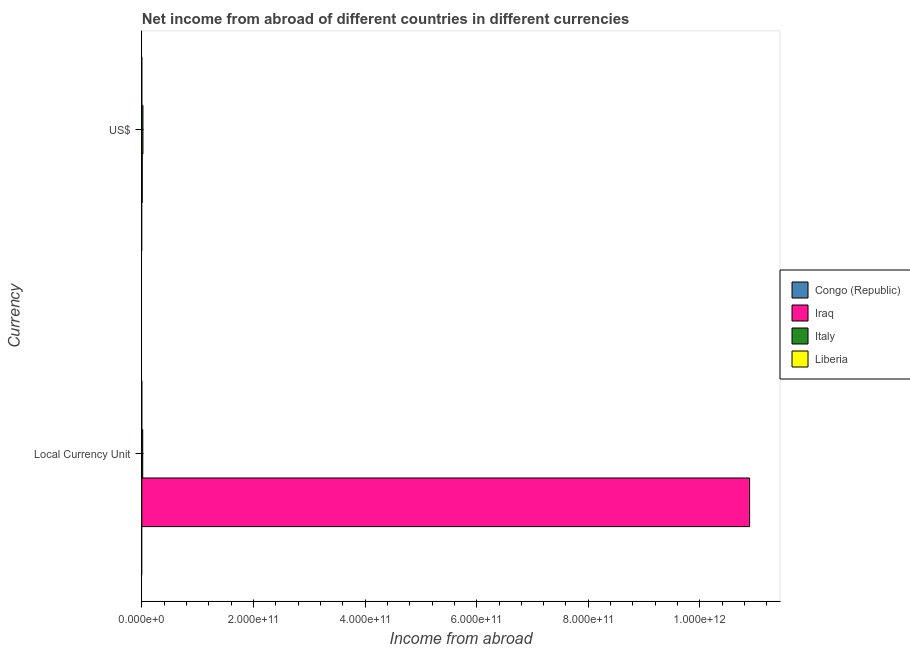Are the number of bars on each tick of the Y-axis equal?
Provide a succinct answer. Yes. How many bars are there on the 1st tick from the bottom?
Provide a succinct answer. 2. What is the label of the 1st group of bars from the top?
Provide a short and direct response. US$. What is the income from abroad in constant 2005 us$ in Italy?
Offer a terse response. 1.65e+09. Across all countries, what is the maximum income from abroad in us$?
Offer a very short reply. 2.06e+09. What is the total income from abroad in us$ in the graph?
Your answer should be compact. 2.80e+09. What is the difference between the income from abroad in us$ in Iraq and that in Italy?
Provide a succinct answer. -1.32e+09. What is the difference between the income from abroad in constant 2005 us$ in Italy and the income from abroad in us$ in Iraq?
Provide a succinct answer. 9.14e+08. What is the average income from abroad in constant 2005 us$ per country?
Keep it short and to the point. 2.73e+11. What is the difference between the income from abroad in us$ and income from abroad in constant 2005 us$ in Italy?
Provide a succinct answer. 4.03e+08. What is the ratio of the income from abroad in constant 2005 us$ in Italy to that in Iraq?
Offer a very short reply. 0. In how many countries, is the income from abroad in us$ greater than the average income from abroad in us$ taken over all countries?
Ensure brevity in your answer.  2. How many countries are there in the graph?
Give a very brief answer. 4. What is the difference between two consecutive major ticks on the X-axis?
Provide a short and direct response. 2.00e+11. Are the values on the major ticks of X-axis written in scientific E-notation?
Give a very brief answer. Yes. Does the graph contain any zero values?
Ensure brevity in your answer.  Yes. Does the graph contain grids?
Your answer should be very brief. No. What is the title of the graph?
Keep it short and to the point. Net income from abroad of different countries in different currencies. What is the label or title of the X-axis?
Offer a terse response. Income from abroad. What is the label or title of the Y-axis?
Offer a very short reply. Currency. What is the Income from abroad in Congo (Republic) in Local Currency Unit?
Provide a succinct answer. 0. What is the Income from abroad in Iraq in Local Currency Unit?
Provide a succinct answer. 1.09e+12. What is the Income from abroad in Italy in Local Currency Unit?
Offer a very short reply. 1.65e+09. What is the Income from abroad in Liberia in Local Currency Unit?
Give a very brief answer. 0. What is the Income from abroad of Congo (Republic) in US$?
Provide a short and direct response. 0. What is the Income from abroad of Iraq in US$?
Make the answer very short. 7.40e+08. What is the Income from abroad of Italy in US$?
Your answer should be compact. 2.06e+09. Across all Currency, what is the maximum Income from abroad of Iraq?
Ensure brevity in your answer.  1.09e+12. Across all Currency, what is the maximum Income from abroad in Italy?
Ensure brevity in your answer.  2.06e+09. Across all Currency, what is the minimum Income from abroad in Iraq?
Offer a terse response. 7.40e+08. Across all Currency, what is the minimum Income from abroad in Italy?
Your answer should be compact. 1.65e+09. What is the total Income from abroad of Congo (Republic) in the graph?
Give a very brief answer. 0. What is the total Income from abroad in Iraq in the graph?
Make the answer very short. 1.09e+12. What is the total Income from abroad in Italy in the graph?
Provide a succinct answer. 3.71e+09. What is the total Income from abroad of Liberia in the graph?
Your answer should be very brief. 0. What is the difference between the Income from abroad of Iraq in Local Currency Unit and that in US$?
Keep it short and to the point. 1.09e+12. What is the difference between the Income from abroad in Italy in Local Currency Unit and that in US$?
Your response must be concise. -4.03e+08. What is the difference between the Income from abroad in Iraq in Local Currency Unit and the Income from abroad in Italy in US$?
Provide a succinct answer. 1.09e+12. What is the average Income from abroad of Congo (Republic) per Currency?
Your response must be concise. 0. What is the average Income from abroad of Iraq per Currency?
Make the answer very short. 5.45e+11. What is the average Income from abroad in Italy per Currency?
Your response must be concise. 1.86e+09. What is the average Income from abroad of Liberia per Currency?
Your answer should be compact. 0. What is the difference between the Income from abroad of Iraq and Income from abroad of Italy in Local Currency Unit?
Your answer should be compact. 1.09e+12. What is the difference between the Income from abroad in Iraq and Income from abroad in Italy in US$?
Offer a very short reply. -1.32e+09. What is the ratio of the Income from abroad of Iraq in Local Currency Unit to that in US$?
Ensure brevity in your answer.  1472. What is the ratio of the Income from abroad of Italy in Local Currency Unit to that in US$?
Provide a succinct answer. 0.8. What is the difference between the highest and the second highest Income from abroad of Iraq?
Your response must be concise. 1.09e+12. What is the difference between the highest and the second highest Income from abroad of Italy?
Offer a terse response. 4.03e+08. What is the difference between the highest and the lowest Income from abroad in Iraq?
Keep it short and to the point. 1.09e+12. What is the difference between the highest and the lowest Income from abroad of Italy?
Offer a terse response. 4.03e+08. 